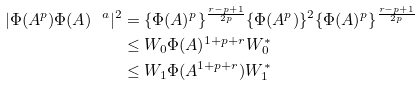Convert formula to latex. <formula><loc_0><loc_0><loc_500><loc_500>| \Phi ( A ^ { p } ) \Phi ( A ) ^ { \ a } | ^ { 2 } & = \{ \Phi ( A ) ^ { p } \} ^ { \frac { r - p + 1 } { 2 p } } \{ \Phi ( A ^ { p } ) \} ^ { 2 } \{ \Phi ( A ) ^ { p } \} ^ { \frac { r - p + 1 } { 2 p } } \\ & \leq W _ { 0 } \Phi ( A ) ^ { 1 + p + r } W ^ { * } _ { 0 } \\ & \leq W _ { 1 } \Phi ( A ^ { 1 + p + r } ) W _ { 1 } ^ { * }</formula> 